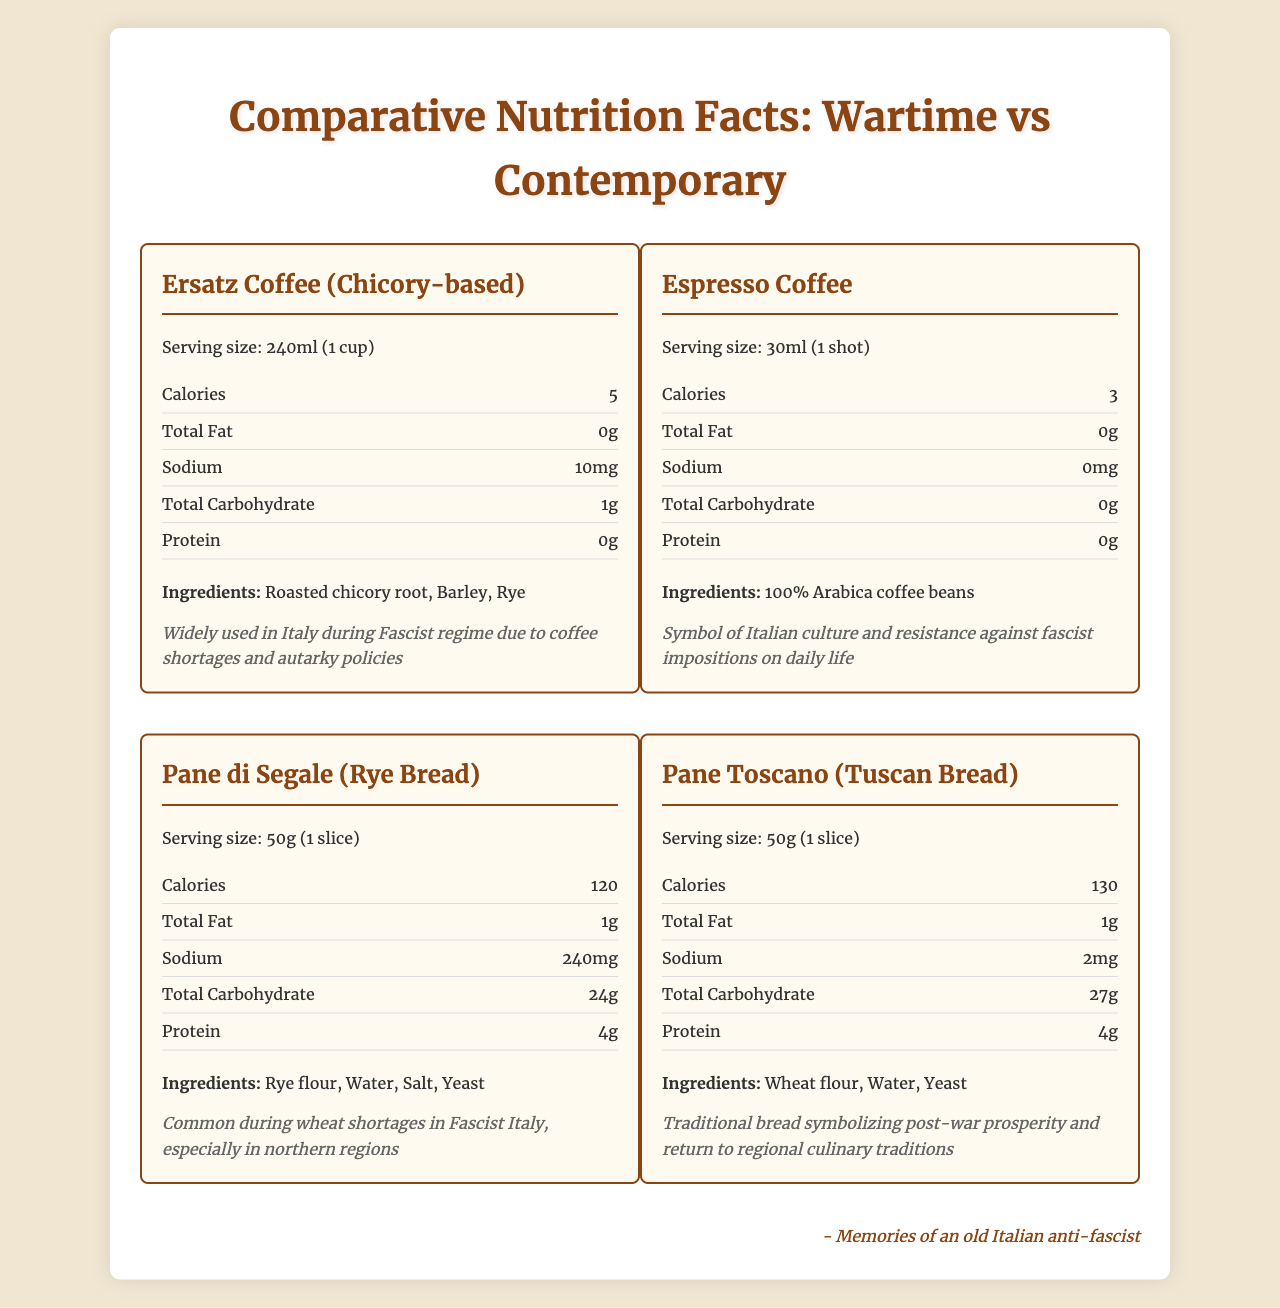what are the main ingredients in the "Ersatz Coffee (Chicory-based)"? The ingredients are listed under the "Ingredients" section for the "Ersatz Coffee (Chicory-based)".
Answer: Roasted chicory root, Barley, Rye what is the serving size of "Pane Toscano"? The serving size is specified at the top of the label under the name "Pane Toscano".
Answer: 50g (1 slice) how much sodium is in a serving of "Espresso Coffee"? The sodium content is listed in the nutrient section for "Espresso Coffee," showing 0mg.
Answer: 0mg compare the caloric content between "Pane di Segale" and "Pane Toscano". Which one contains more calories? "Pane di Segale" has 120 calories per serving, whereas "Pane Toscano" has 130 calories per serving.
Answer: Pane Toscano contains more calories. what is the historical context for "Ersatz Coffee (Chicory-based)"? The historical context is mentioned at the end of the "Ersatz Coffee (Chicory-based)" label.
Answer: Widely used in Italy during Fascist regime due to coffee shortages and autarky policies which substitute has the highest amount of protein? A. Ersatz Coffee (Chicory-based) B. Espresso Coffee C. Pane di Segale D. Pane Toscano "Pane di Segale" has 4g of protein per serving, which is the highest among the listed items.
Answer: C which ingredient is not found in "Espresso Coffee"? A. Rye B. Chicory Root C. 100% Arabica Coffee Beans "Rye" is not an ingredient in "Espresso Coffee"; the ingredients listed are "100% Arabica Coffee Beans".
Answer: A Is "Espresso Coffee" a product of post-war prosperity and a return to regional culinary traditions? The historical context of "Espresso Coffee" mentions it as a symbol of Italian culture and resistance against fascist impositions on daily life, not post-war prosperity.
Answer: No summarize the main idea of the entire document. The document showcases the nutritional facts and ingredients for four food items, two from wartime and two contemporary, highlighting the differences and historical significance of each pair.
Answer: The document presents a comparative analysis of nutritional information between wartime food substitutes and their contemporary alternatives, providing historical context for their usage during the Fascist regime and post-war Italy. what year was "Ersatz Coffee" most popular? The document does not provide specific years for the popularity of "Ersatz Coffee"; it only mentions it was widely used during the Fascist regime.
Answer: Cannot be determined 